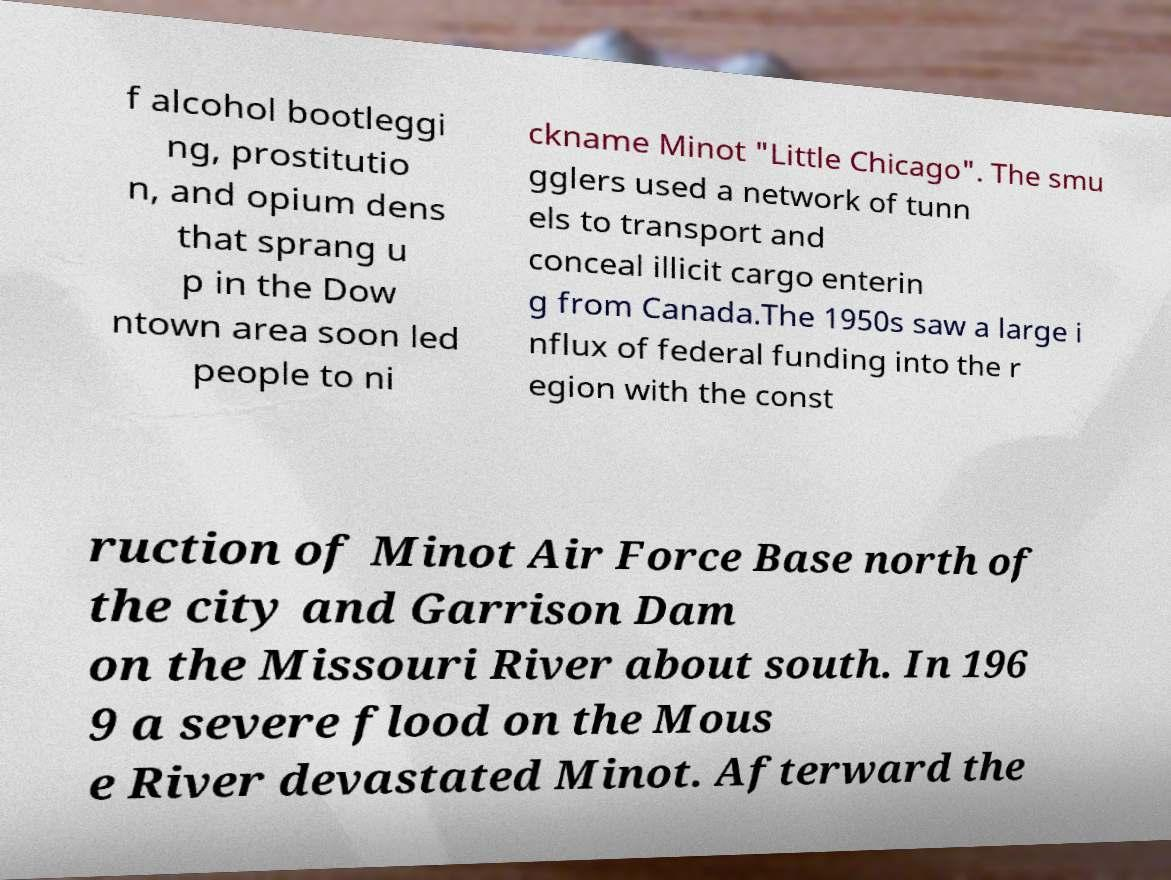Please read and relay the text visible in this image. What does it say? f alcohol bootleggi ng, prostitutio n, and opium dens that sprang u p in the Dow ntown area soon led people to ni ckname Minot "Little Chicago". The smu gglers used a network of tunn els to transport and conceal illicit cargo enterin g from Canada.The 1950s saw a large i nflux of federal funding into the r egion with the const ruction of Minot Air Force Base north of the city and Garrison Dam on the Missouri River about south. In 196 9 a severe flood on the Mous e River devastated Minot. Afterward the 